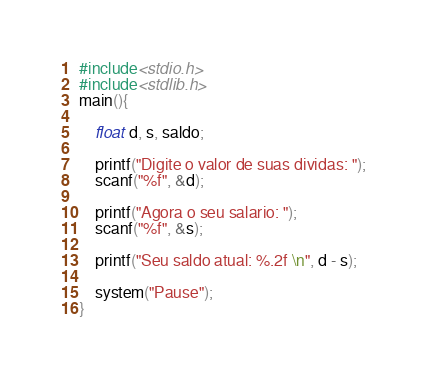Convert code to text. <code><loc_0><loc_0><loc_500><loc_500><_C++_>#include<stdio.h>
#include<stdlib.h>
main(){
	
	float d, s, saldo;
	
	printf("Digite o valor de suas dividas: ");
	scanf("%f", &d);
	
	printf("Agora o seu salario: ");
	scanf("%f", &s);
	
	printf("Seu saldo atual: %.2f \n", d - s);
	
	system("Pause");
}
</code> 